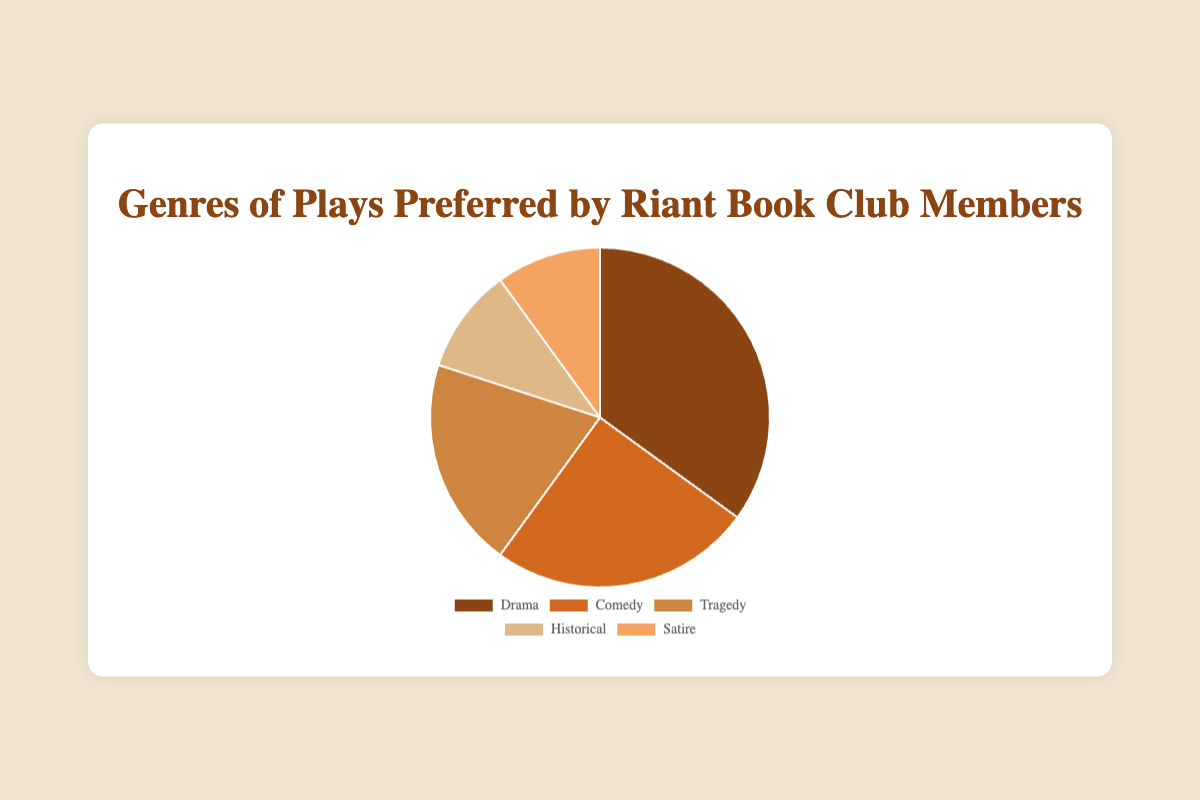What genre of play is the most preferred by Riant Book Club members? The chart shows percentage preferences, and the largest portion belongs to Drama at 35%.
Answer: Drama Which genre has the least preference among the Riant Book Club members? By observing the chart, Historical and Satire each have the smallest slices, both at 10%.
Answer: Historical and Satire How much more popular is Drama compared to Tragedy? Drama has 35% and Tragedy has 20%. The difference is 35% - 20% = 15%.
Answer: 15% What is the combined preference percentage for Historical and Satire genres? Historical and Satire each have 10%. Combined, 10% + 10% = 20%.
Answer: 20% Which genre is preferred by 25% of members? The chart shows that Comedy is preferred by 25% of the members.
Answer: Comedy If you combined the percentages of Comedy, Tragedy, and Satire, what would the total be? Comedy is 25%, Tragedy is 20%, and Satire is 10%. The sum is 25% + 20% + 10% = 55%.
Answer: 55% How does the preference for Comedy compare to that for Historical and Satire combined? Comedy is preferred by 25%, and Historical plus Satire together are 20%. 25% is greater than 20%.
Answer: Comedy is preferred more Which color corresponds to the Historical genre? The chart shows the Historical genre in a lighter brown color, deb887.
Answer: Light Brown What percentage of the members prefer genres other than Drama? The percentages for the genres other than Drama (35%) are: 25% (Comedy) + 20% (Tragedy) + 10% (Historical) + 10% (Satire). The sum is 25% + 20% + 10% + 10% = 65%.
Answer: 65% 